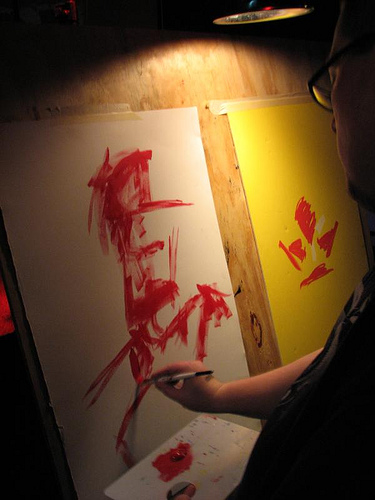<image>
Is the painting behind the man? No. The painting is not behind the man. From this viewpoint, the painting appears to be positioned elsewhere in the scene. 